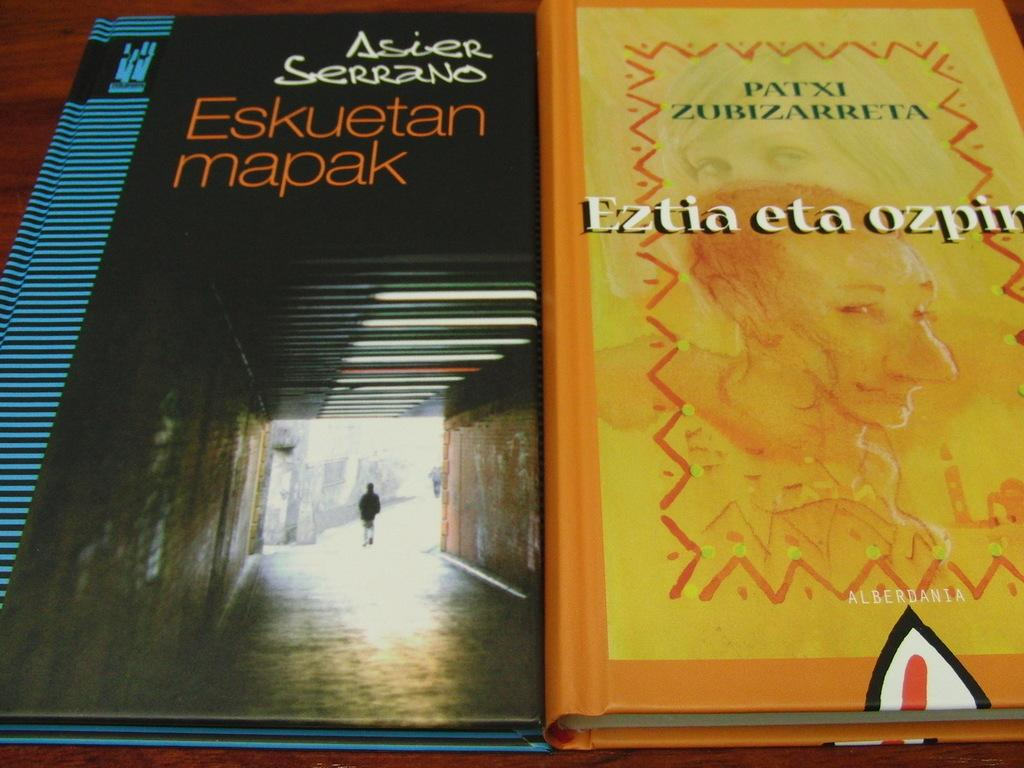<image>
Create a compact narrative representing the image presented. Two books next to each other, one of which is title "Eskuetan mapak". 